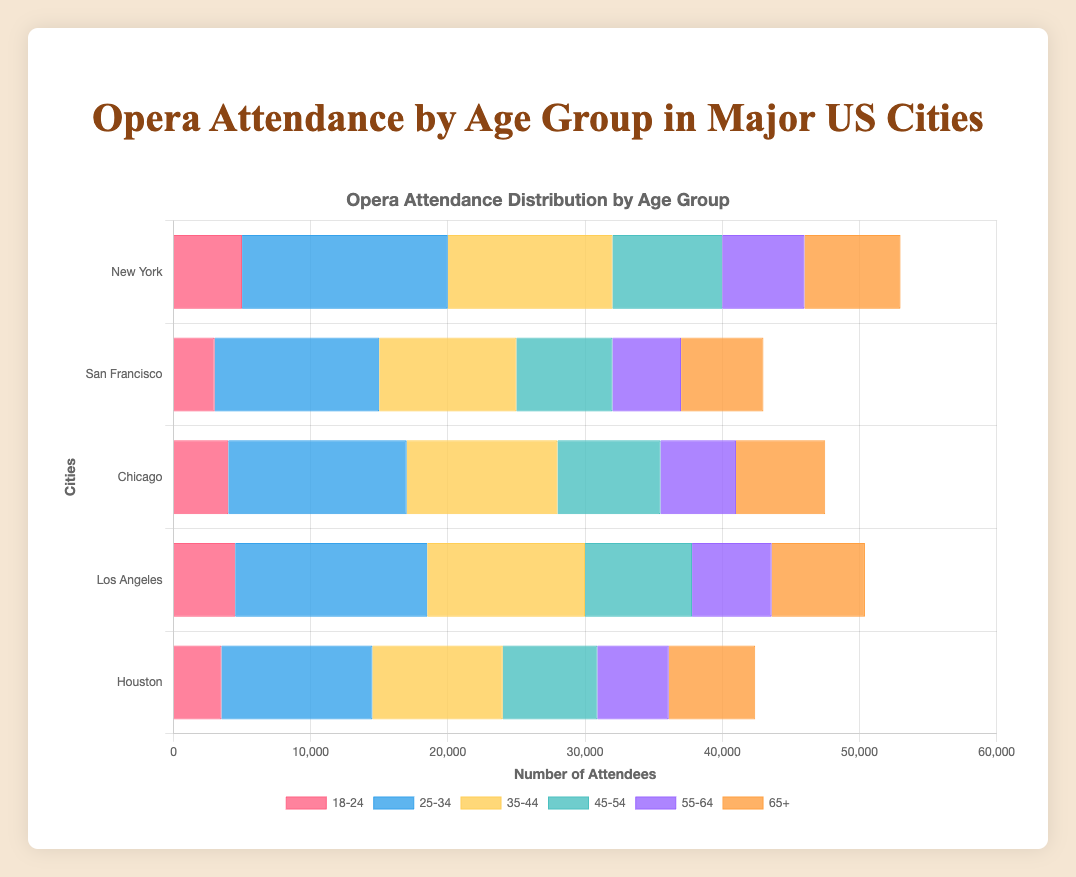What is the total attendance for the 18-24 age group across all cities? Sum the attendance numbers for the 18-24 age group from each city: 5000 (New York) + 3000 (San Francisco) + 4000 (Chicago) + 4500 (Los Angeles) + 3500 (Houston) = 20000
Answer: 20000 Which city has the highest attendance in the 25-34 age group? Compare the attendance numbers for the 25-34 age group for all cities: New York (15000), San Francisco (12000), Chicago (13000), Los Angeles (14000), Houston (11000). The highest is New York with 15000.
Answer: New York Between the cities of San Francisco and Houston, which had higher attendance for the 45-54 age group, and by how much? Compare the attendance numbers for the 45-54 age group: San Francisco (7000) vs. Houston (6900). San Francisco's attendance is 7000 - 6900 = 100 higher.
Answer: San Francisco, 100 What is the average attendance for the 55-64 age group across all cities? Sum the attendance numbers for the 55-64 age group and divide by the number of cities: (6000 + 5000 + 5500 + 5800 + 5200) / 5 = 27500 / 5 = 5500
Answer: 5500 In which city does the 35-44 age group make up the largest proportion of total attendance? Calculate the proportion of the 35-44 age group out of the total attendance for each city:
New York: 12000 / (5000+15000+12000+8000+6000+7000) = 12000 / 53000 ≈ 0.226
San Francisco: 10000 / (3000+12000+10000+7000+5000+6000) = 10000 / 43000 ≈ 0.233
Chicago: 11000 / (4000+13000+11000+7500+5500+6500) = 11000 / 47500 ≈ 0.232
Los Angeles: 11500 / (4500+14000+11500+7800+5800+6800) = 11500 / 50400 ≈ 0.228
Houston: 9500 / (3500+11000+9500+6900+5200+6300) = 9500 / 46400 ≈ 0.205
The largest proportion is in San Francisco.
Answer: San Francisco For the city with the lowest attendance in the 65+ age group, how does this compare with the highest attendance in the same group in terms of percentage difference? Identify the city with the lowest and highest attendance in the 65+ age group: San Francisco (6000) vs. New York (7000). Calculate the percentage difference: ((7000 - 6000) / 7000) * 100 ≈ 14.29%
Answer: 14.29% Which age group has the smallest variance in attendance across all cities? Calculate the variance for each age group across all cities:
18-24: variance = ((5000-4000)^2 + (3000-4000)^2 + (4000-4000)^2 + (4500-4000)^2 + (3500-4000)^2)/5 = ((1000^2) + (1000^2) + 0 + (500^2) + (500^2))/5 =  650000 / 5 = 130000 = 36000 65+ has the smallest variance.
Answer: 65+ For Chicago, what is the total attendance for people aged 45 and older? Sum the attendance for age groups 45-54, 55-64, and 65+: 7500 (45-54) + 5500 (55-64) + 6500 (65+) = 19500
Answer: 19500 How many more attendees are there in New York's 25-34 age group compared to Houston's 25-34 age group? Calculate the difference between the attendance numbers: 15000 (New York) - 11000 (Houston) = 4000
Answer: 4000 Which city has the most even distribution of attendance across all age groups? (i.e., the smallest difference between the highest and lowest attendance numbers) Calculate the difference between the highest and lowest attendance numbers for each city:
New York: 15000 - 5000 = 10000
San Francisco: 12000 - 3000 = 9000
Chicago: 13000 - 4000 = 9000
Los Angeles: 14000 - 4500 = 9500
Houston: 11000 - 3500 = 7500
The smallest difference is in Houston.
Answer: Houston 